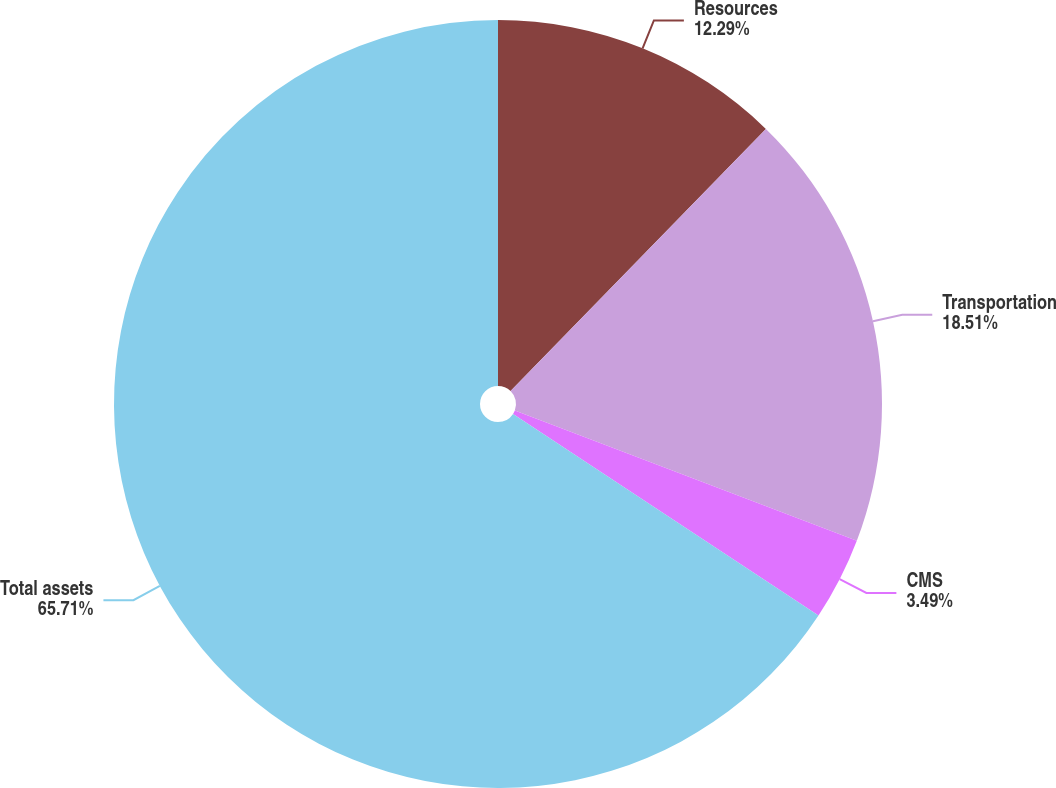<chart> <loc_0><loc_0><loc_500><loc_500><pie_chart><fcel>Resources<fcel>Transportation<fcel>CMS<fcel>Total assets<nl><fcel>12.29%<fcel>18.51%<fcel>3.49%<fcel>65.72%<nl></chart> 